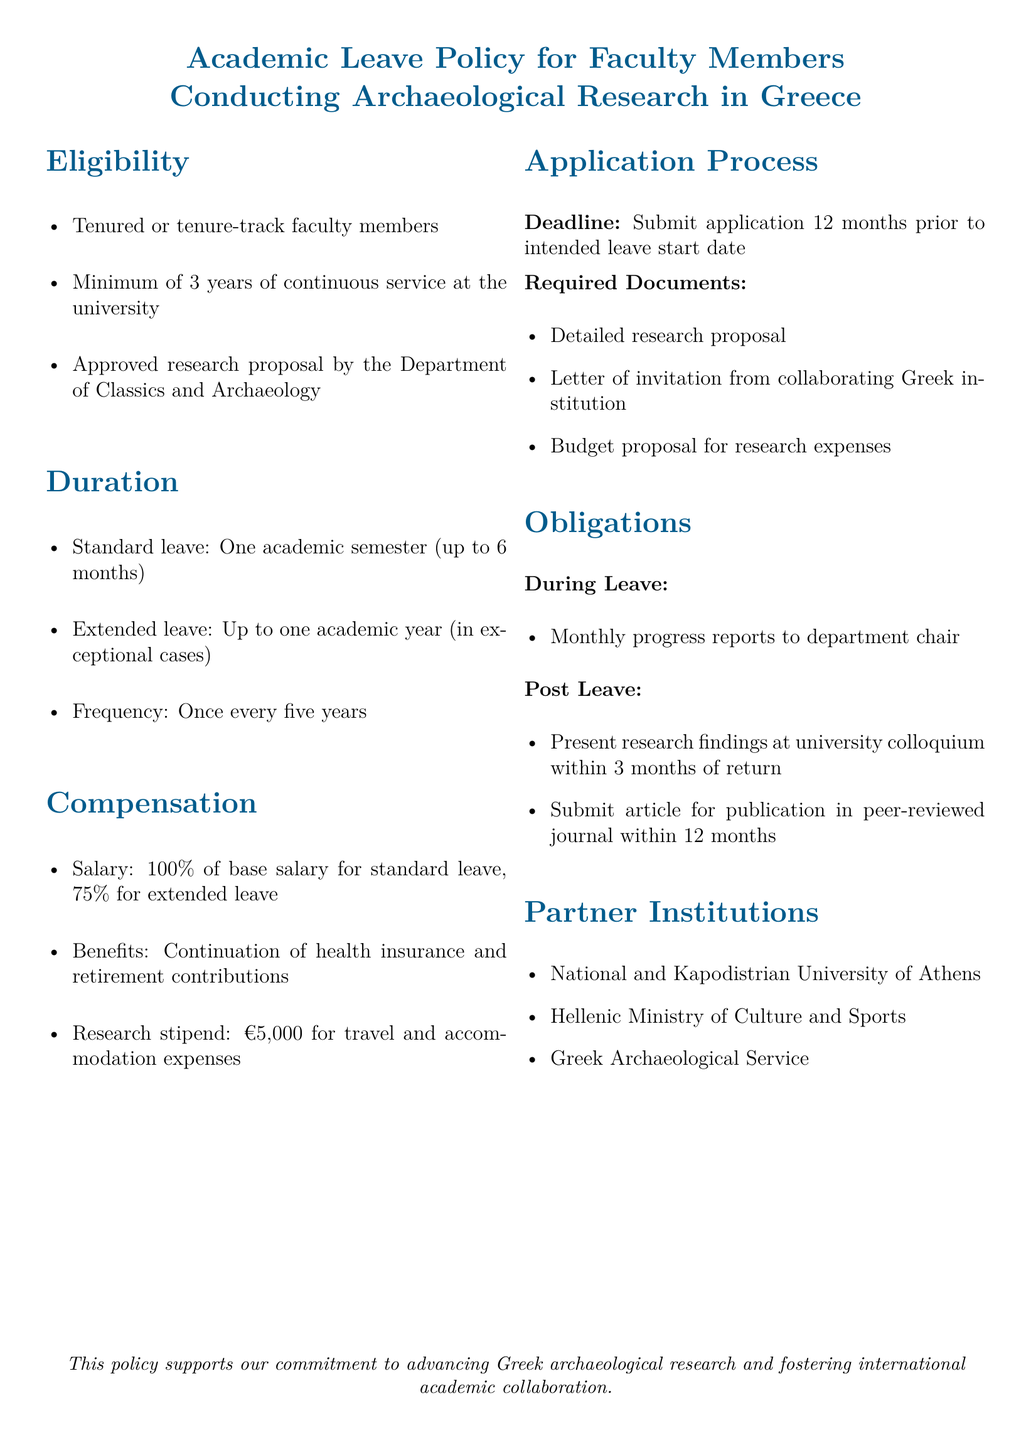What is the minimum service duration for eligibility? The document states that faculty members must have a minimum of 3 years of continuous service at the university to be eligible.
Answer: 3 years What is the standard duration of academic leave? The standard leave duration outlined in the document is one academic semester, which can be up to 6 months.
Answer: One academic semester (up to 6 months) What percentage of salary is paid during extended leave? The compensation section explicitly states that faculty members receive 75% of their base salary during extended leave.
Answer: 75% How often can a faculty member take academic leave? The document mentions that faculty members can take academic leave once every five years.
Answer: Once every five years What is the amount of the research stipend? The document specifies that the research stipend provided for travel and accommodation expenses is €5,000.
Answer: €5,000 What must faculty submit 12 months prior to leave? The required submission is an application, which must be submitted 12 months before the intended leave start date according to the application process section.
Answer: Application What is a post-leave obligation for faculty members? Faculty members are obligated to present their research findings at a university colloquium within 3 months of their return.
Answer: Present research findings at university colloquium Which institution is NOT listed as a partner institution? The document includes specific partner institutions, and if a name not mentioned is asked, it would be answered as not being included.
Answer: (varies with given options) 